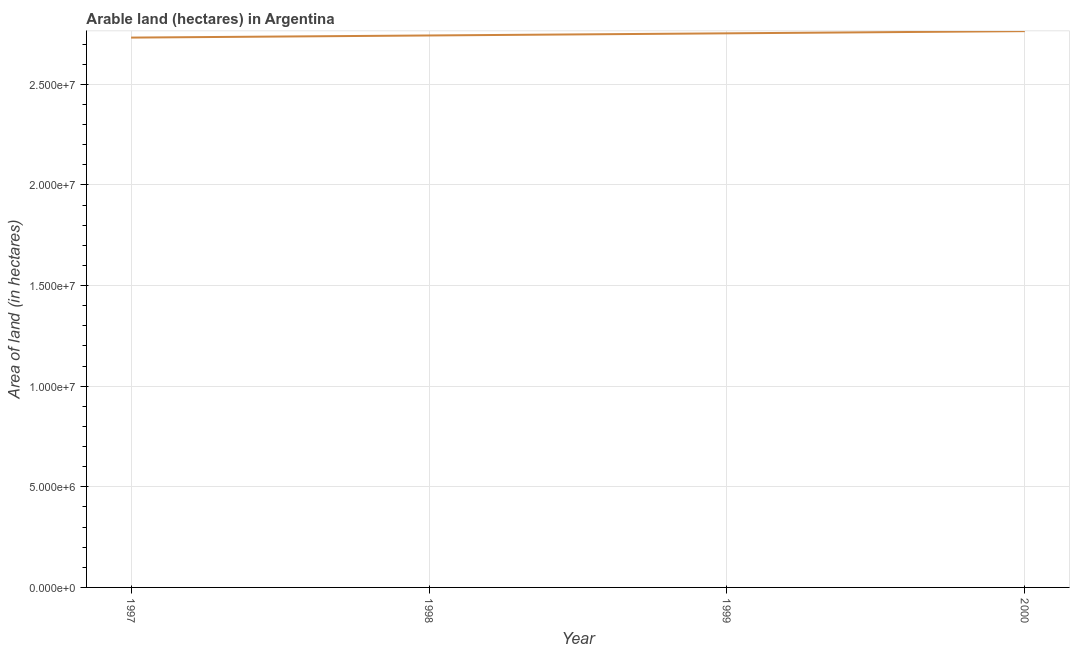What is the area of land in 2000?
Provide a succinct answer. 2.76e+07. Across all years, what is the maximum area of land?
Provide a succinct answer. 2.76e+07. Across all years, what is the minimum area of land?
Offer a terse response. 2.73e+07. In which year was the area of land minimum?
Your response must be concise. 1997. What is the sum of the area of land?
Your response must be concise. 1.10e+08. What is the difference between the area of land in 1997 and 2000?
Give a very brief answer. -3.20e+05. What is the average area of land per year?
Your answer should be very brief. 2.75e+07. What is the median area of land?
Keep it short and to the point. 2.75e+07. In how many years, is the area of land greater than 9000000 hectares?
Provide a succinct answer. 4. Do a majority of the years between 1997 and 2000 (inclusive) have area of land greater than 13000000 hectares?
Provide a succinct answer. Yes. What is the ratio of the area of land in 1997 to that in 1998?
Your answer should be very brief. 1. Is the area of land in 1997 less than that in 1999?
Make the answer very short. Yes. Is the difference between the area of land in 1999 and 2000 greater than the difference between any two years?
Offer a very short reply. No. What is the difference between the highest and the second highest area of land?
Ensure brevity in your answer.  1.08e+05. Is the sum of the area of land in 1997 and 1999 greater than the maximum area of land across all years?
Ensure brevity in your answer.  Yes. What is the difference between the highest and the lowest area of land?
Your response must be concise. 3.20e+05. How many years are there in the graph?
Make the answer very short. 4. What is the difference between two consecutive major ticks on the Y-axis?
Offer a terse response. 5.00e+06. Are the values on the major ticks of Y-axis written in scientific E-notation?
Offer a very short reply. Yes. What is the title of the graph?
Give a very brief answer. Arable land (hectares) in Argentina. What is the label or title of the X-axis?
Keep it short and to the point. Year. What is the label or title of the Y-axis?
Make the answer very short. Area of land (in hectares). What is the Area of land (in hectares) of 1997?
Your answer should be very brief. 2.73e+07. What is the Area of land (in hectares) of 1998?
Give a very brief answer. 2.74e+07. What is the Area of land (in hectares) of 1999?
Provide a short and direct response. 2.75e+07. What is the Area of land (in hectares) of 2000?
Provide a succinct answer. 2.76e+07. What is the difference between the Area of land (in hectares) in 1997 and 1998?
Provide a succinct answer. -1.05e+05. What is the difference between the Area of land (in hectares) in 1997 and 1999?
Your answer should be very brief. -2.12e+05. What is the difference between the Area of land (in hectares) in 1997 and 2000?
Offer a terse response. -3.20e+05. What is the difference between the Area of land (in hectares) in 1998 and 1999?
Give a very brief answer. -1.07e+05. What is the difference between the Area of land (in hectares) in 1998 and 2000?
Ensure brevity in your answer.  -2.15e+05. What is the difference between the Area of land (in hectares) in 1999 and 2000?
Provide a succinct answer. -1.08e+05. What is the ratio of the Area of land (in hectares) in 1998 to that in 1999?
Your answer should be compact. 1. What is the ratio of the Area of land (in hectares) in 1999 to that in 2000?
Your answer should be compact. 1. 